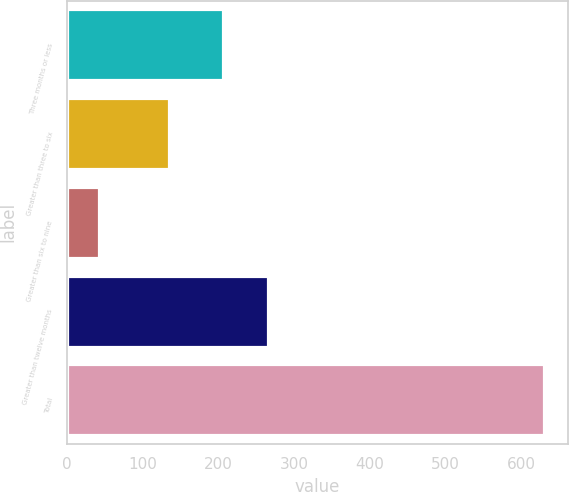<chart> <loc_0><loc_0><loc_500><loc_500><bar_chart><fcel>Three months or less<fcel>Greater than three to six<fcel>Greater than six to nine<fcel>Greater than twelve months<fcel>Total<nl><fcel>206<fcel>134<fcel>42<fcel>264.8<fcel>630<nl></chart> 